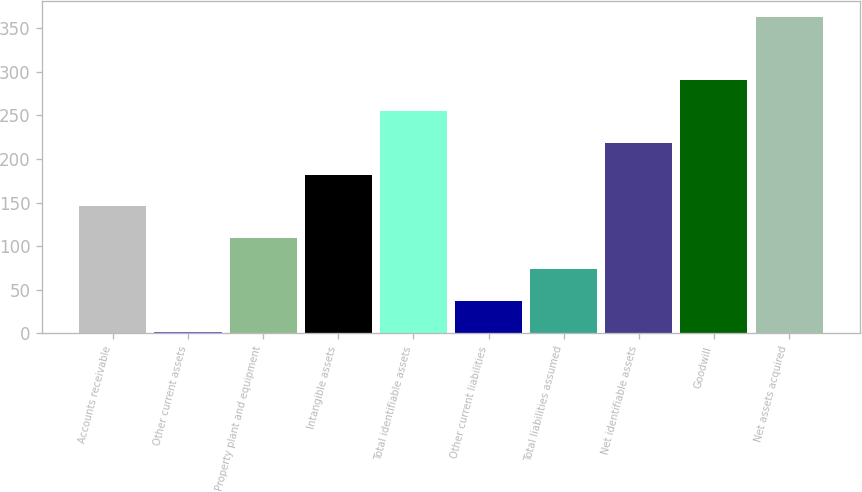<chart> <loc_0><loc_0><loc_500><loc_500><bar_chart><fcel>Accounts receivable<fcel>Other current assets<fcel>Property plant and equipment<fcel>Intangible assets<fcel>Total identifiable assets<fcel>Other current liabilities<fcel>Total liabilities assumed<fcel>Net identifiable assets<fcel>Goodwill<fcel>Net assets acquired<nl><fcel>145.8<fcel>1<fcel>109.6<fcel>182<fcel>254.4<fcel>37.2<fcel>73.4<fcel>218.2<fcel>290.6<fcel>363<nl></chart> 